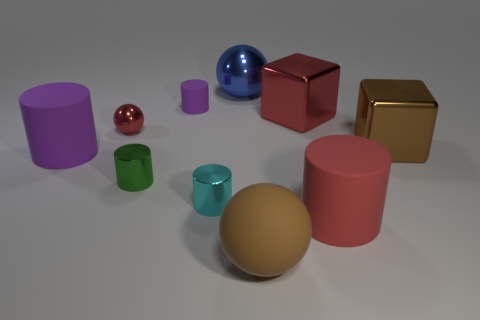Is the number of tiny shiny things greater than the number of large green rubber cubes?
Your answer should be very brief. Yes. There is another rubber cylinder that is the same color as the tiny matte cylinder; what size is it?
Offer a terse response. Large. The matte object behind the purple rubber cylinder in front of the brown metallic object is what shape?
Make the answer very short. Cylinder. There is a large cube in front of the red object to the left of the small cyan metallic cylinder; are there any brown shiny things that are in front of it?
Give a very brief answer. No. What color is the other cube that is the same size as the brown block?
Your answer should be very brief. Red. There is a thing that is on the left side of the cyan thing and behind the small red metal sphere; what is its shape?
Your response must be concise. Cylinder. There is a metal cube to the right of the red object in front of the cyan cylinder; how big is it?
Give a very brief answer. Large. How many tiny shiny things are the same color as the tiny metallic sphere?
Provide a short and direct response. 0. How many other objects are the same size as the brown metallic object?
Make the answer very short. 5. What is the size of the metal object that is in front of the large brown block and to the right of the tiny purple cylinder?
Your answer should be compact. Small. 